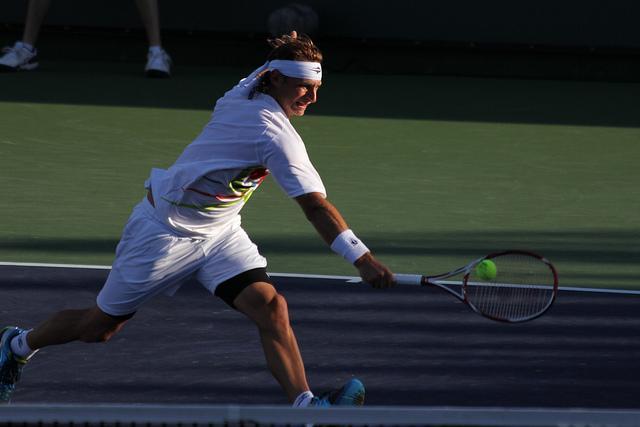How many people are there?
Give a very brief answer. 2. 